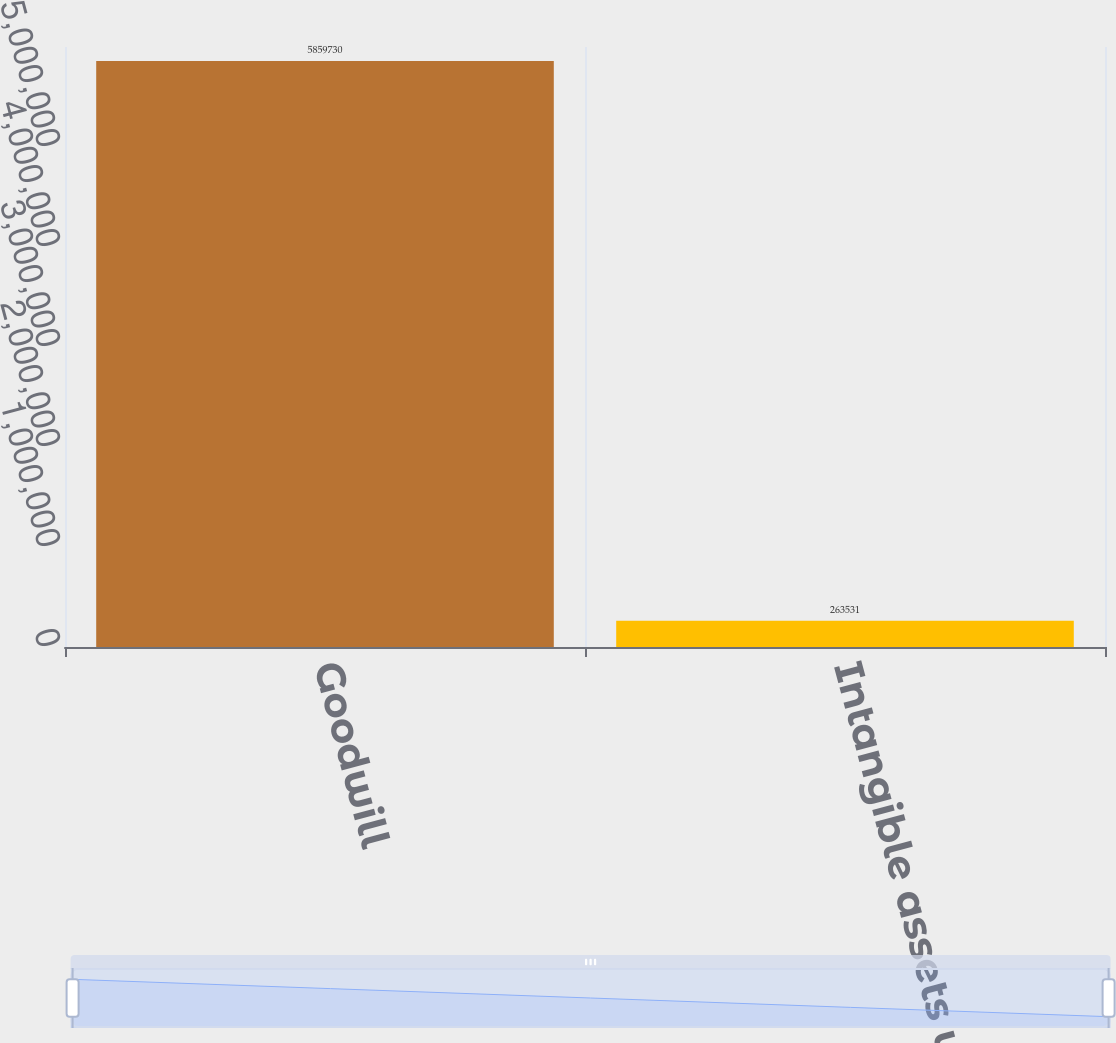<chart> <loc_0><loc_0><loc_500><loc_500><bar_chart><fcel>Goodwill<fcel>Intangible assets with<nl><fcel>5.85973e+06<fcel>263531<nl></chart> 